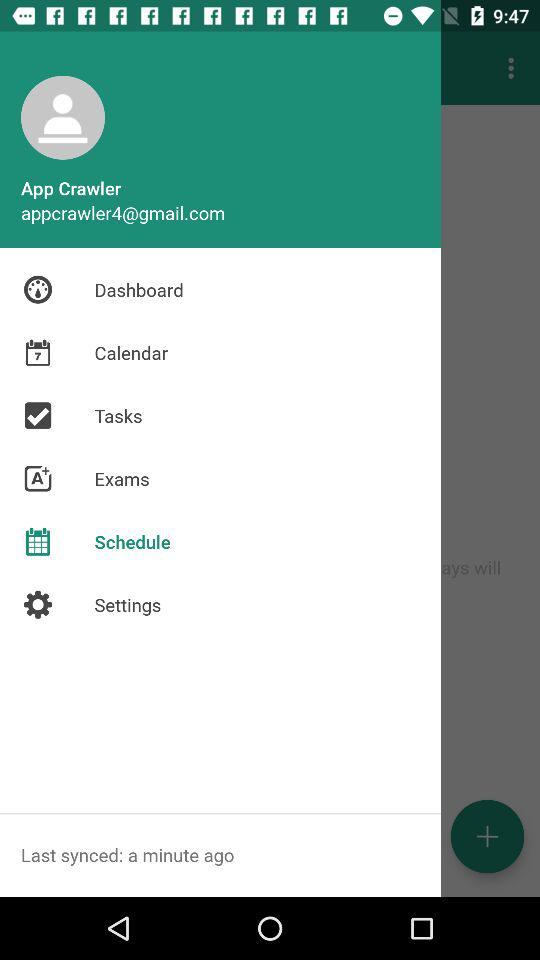When was the last sync? The last sync was a minute ago. 